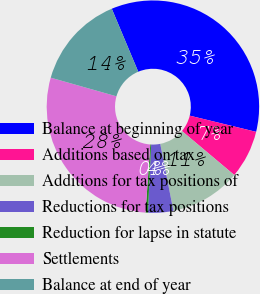Convert chart to OTSL. <chart><loc_0><loc_0><loc_500><loc_500><pie_chart><fcel>Balance at beginning of year<fcel>Additions based on tax<fcel>Additions for tax positions of<fcel>Reductions for tax positions<fcel>Reduction for lapse in statute<fcel>Settlements<fcel>Balance at end of year<nl><fcel>35.14%<fcel>7.31%<fcel>10.79%<fcel>3.84%<fcel>0.36%<fcel>28.29%<fcel>14.27%<nl></chart> 